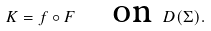<formula> <loc_0><loc_0><loc_500><loc_500>K = f \circ F \quad \text {on } D ( \Sigma ) .</formula> 